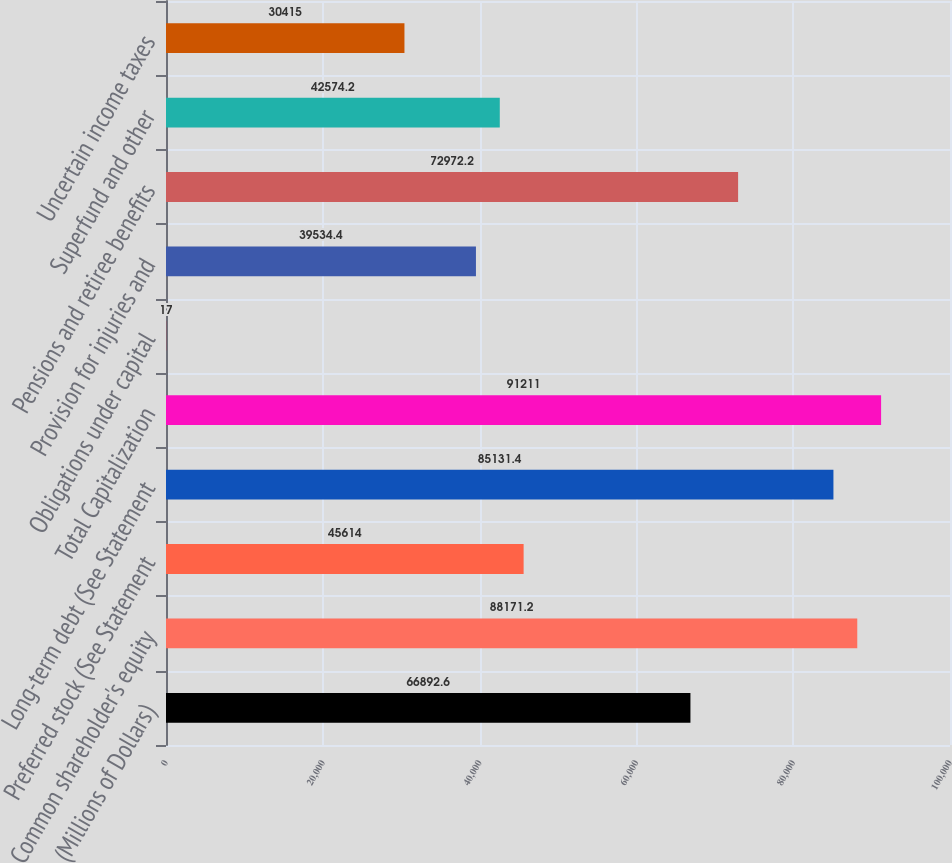Convert chart to OTSL. <chart><loc_0><loc_0><loc_500><loc_500><bar_chart><fcel>(Millions of Dollars)<fcel>Common shareholder's equity<fcel>Preferred stock (See Statement<fcel>Long-term debt (See Statement<fcel>Total Capitalization<fcel>Obligations under capital<fcel>Provision for injuries and<fcel>Pensions and retiree benefits<fcel>Superfund and other<fcel>Uncertain income taxes<nl><fcel>66892.6<fcel>88171.2<fcel>45614<fcel>85131.4<fcel>91211<fcel>17<fcel>39534.4<fcel>72972.2<fcel>42574.2<fcel>30415<nl></chart> 